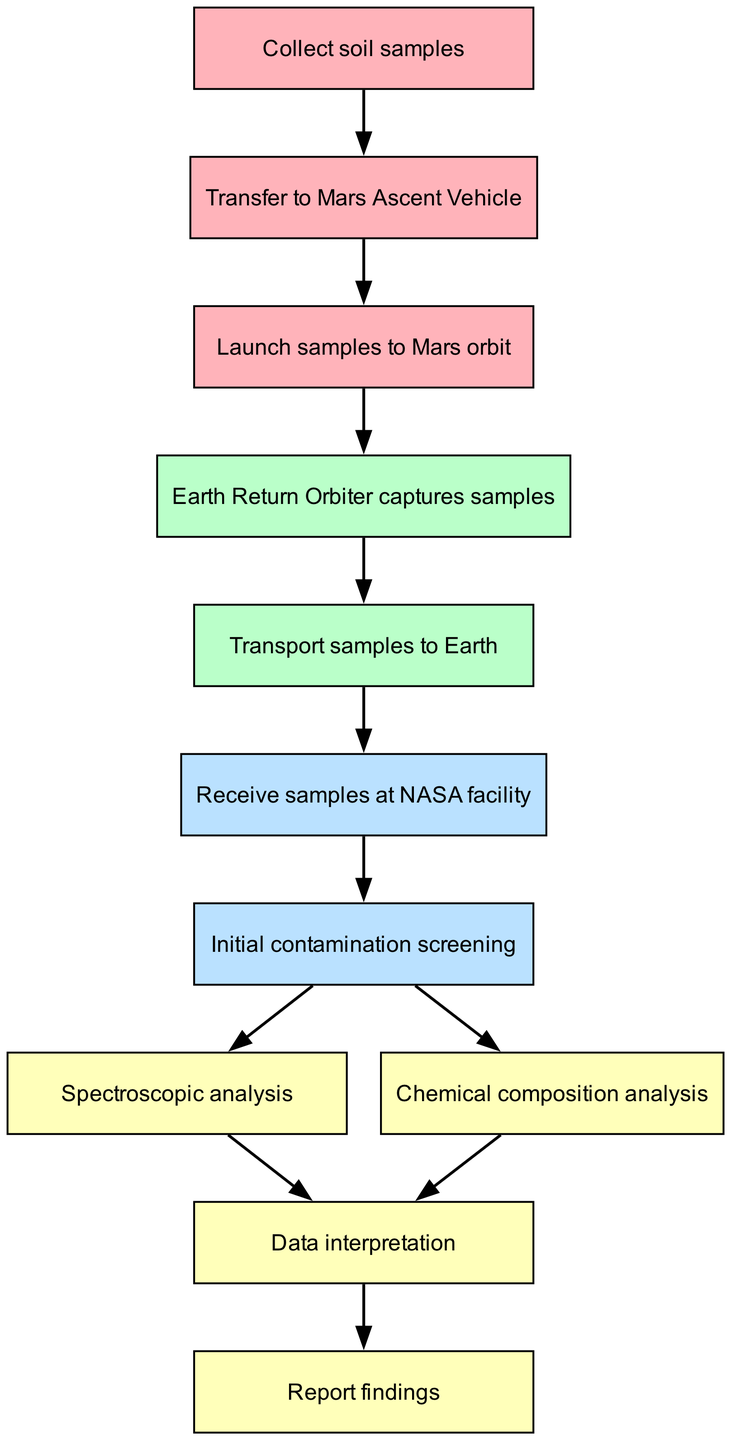What is the first step in the workflow? The first step is represented by the node labeled "Collect soil samples," which is the starting point of the entire flowchart.
Answer: Collect soil samples How many nodes are present in the diagram? By counting all the nodes listed, there are eleven in total, as confirmed by the data provided.
Answer: Eleven What is the last step in the workflow? The final step is indicated by the node labeled "Report findings," which signifies the conclusion of the analysis process.
Answer: Report findings Which two processes occur after the initial contamination screening? The processes that follow are "Spectroscopic analysis" and "Chemical composition analysis," both of which branch out from the initial screening step.
Answer: Spectroscopic analysis and Chemical composition analysis Which node represents the capture of samples? The node labeled "Earth Return Orbiter captures samples" denotes the action of capturing the samples in the workflow.
Answer: Earth Return Orbiter captures samples What color represents the analysis stage nodes? The color used for the analysis stage nodes is light yellow, as indicated in the color scheme for different stages of the workflow.
Answer: Light yellow What is the relationship between the nodes "Launch samples to Mars orbit" and "Transfer to Mars Ascent Vehicle"? The relationship is a directed flow where "Transfer to Mars Ascent Vehicle" is the preceding action that leads to "Launch samples to Mars orbit."
Answer: Directed flow What is the main purpose of the node labeled "Initial contamination screening"? The purpose of this node is to ensure that the soil samples are free from contamination before proceeding to further analysis.
Answer: Ensure samples are free from contamination How do "Spectroscopic analysis" and "Chemical composition analysis" relate to "Data interpretation"? Both "Spectroscopic analysis" and "Chemical composition analysis" provide data that serves as inputs for the "Data interpretation" step that follows.
Answer: Provide data for interpretation 